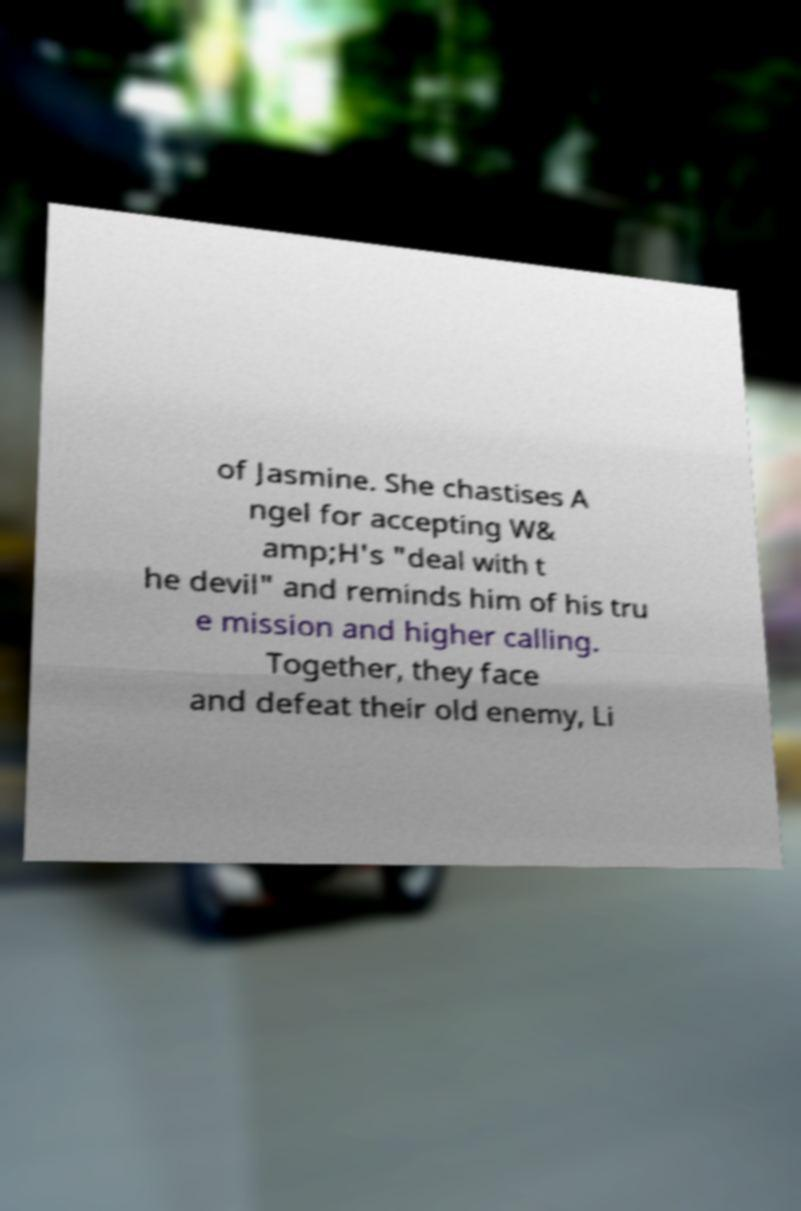For documentation purposes, I need the text within this image transcribed. Could you provide that? of Jasmine. She chastises A ngel for accepting W& amp;H's "deal with t he devil" and reminds him of his tru e mission and higher calling. Together, they face and defeat their old enemy, Li 